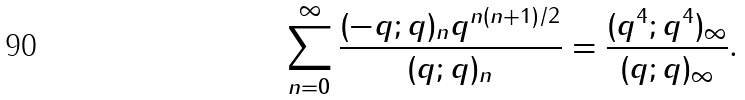<formula> <loc_0><loc_0><loc_500><loc_500>\sum _ { n = 0 } ^ { \infty } \frac { ( - q ; q ) _ { n } q ^ { n ( n + 1 ) / 2 } } { ( q ; q ) _ { n } } = \frac { ( q ^ { 4 } ; q ^ { 4 } ) _ { \infty } } { ( q ; q ) _ { \infty } } .</formula> 